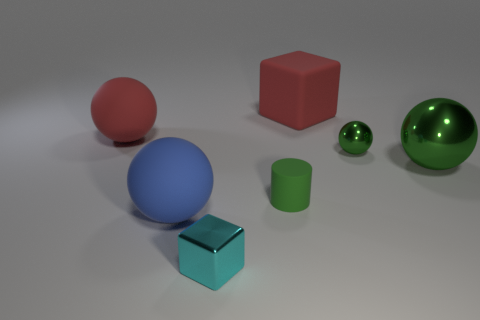What is the shape of the blue object?
Offer a very short reply. Sphere. Is the material of the cyan block the same as the block behind the large metal object?
Provide a short and direct response. No. What number of metallic things are cyan objects or green spheres?
Your answer should be compact. 3. There is a cyan block in front of the green matte object; what is its size?
Offer a terse response. Small. What is the size of the block that is the same material as the big red sphere?
Keep it short and to the point. Large. What number of balls are the same color as the small metallic cube?
Your answer should be compact. 0. Are any tiny red cylinders visible?
Your answer should be very brief. No. Is the shape of the large blue thing the same as the rubber thing that is on the left side of the blue object?
Your response must be concise. Yes. There is a rubber thing behind the thing on the left side of the big blue ball that is in front of the tiny rubber cylinder; what color is it?
Provide a short and direct response. Red. There is a blue matte thing; are there any big metallic balls in front of it?
Provide a short and direct response. No. 